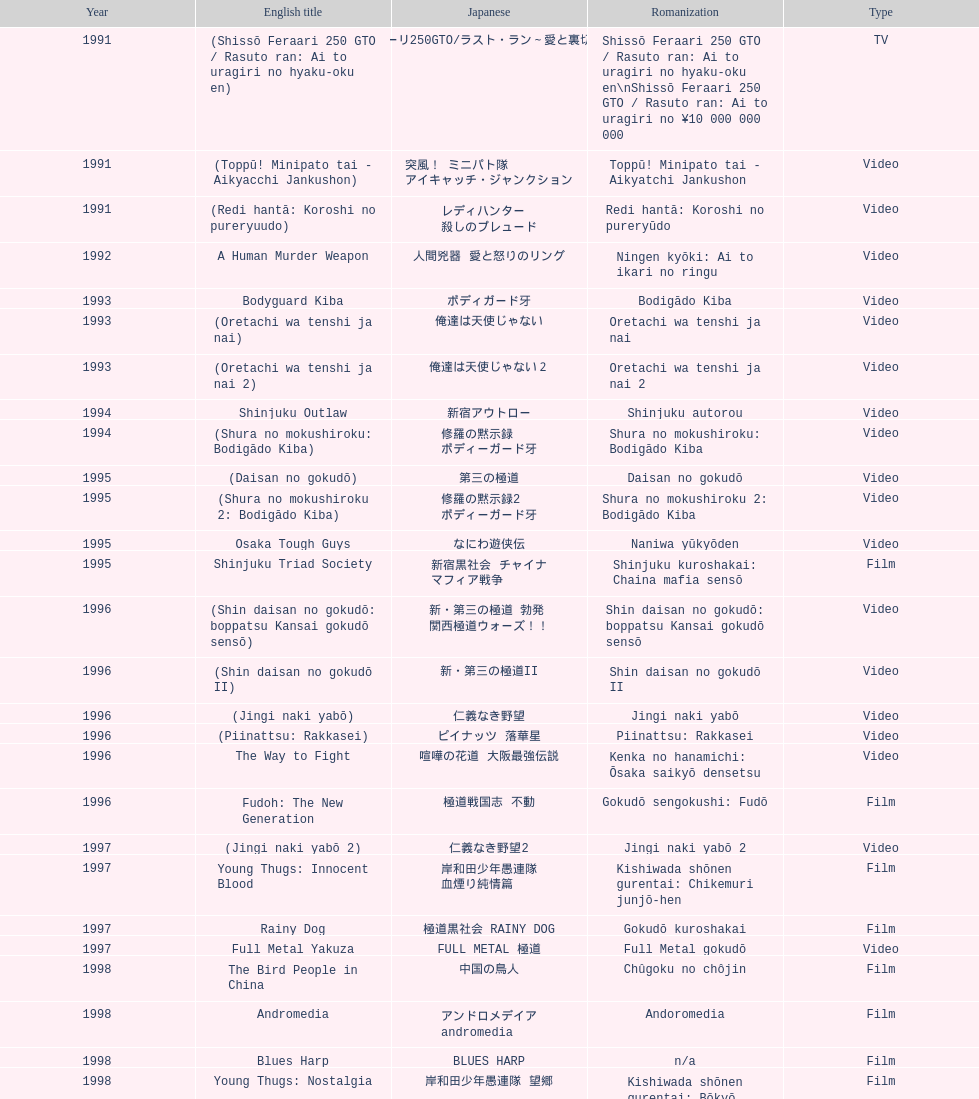What is takashi miike's work with the least amount of years since release? The Mole Song: Undercover Agent Reiji. 